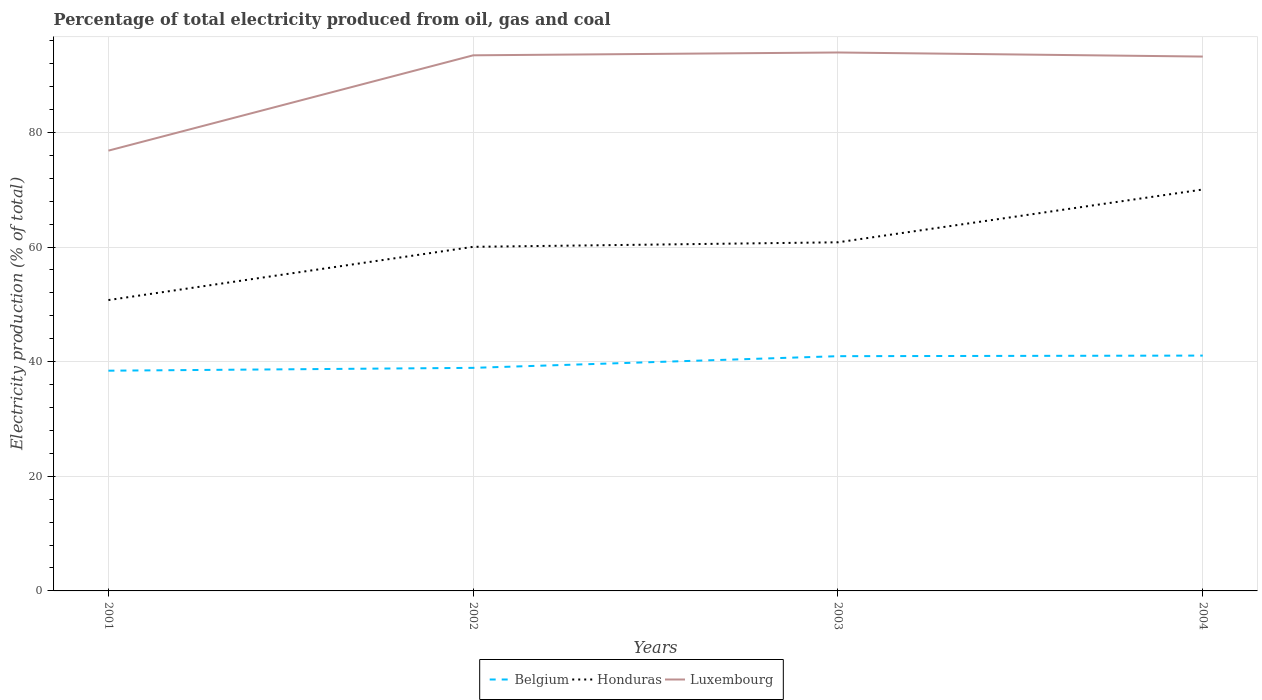How many different coloured lines are there?
Offer a very short reply. 3. Does the line corresponding to Luxembourg intersect with the line corresponding to Honduras?
Make the answer very short. No. Across all years, what is the maximum electricity production in in Belgium?
Offer a very short reply. 38.42. In which year was the electricity production in in Luxembourg maximum?
Provide a succinct answer. 2001. What is the total electricity production in in Belgium in the graph?
Your answer should be very brief. -0.1. What is the difference between the highest and the second highest electricity production in in Honduras?
Keep it short and to the point. 19.29. What is the difference between the highest and the lowest electricity production in in Honduras?
Provide a succinct answer. 2. How many lines are there?
Make the answer very short. 3. Are the values on the major ticks of Y-axis written in scientific E-notation?
Give a very brief answer. No. Does the graph contain any zero values?
Give a very brief answer. No. How many legend labels are there?
Ensure brevity in your answer.  3. How are the legend labels stacked?
Make the answer very short. Horizontal. What is the title of the graph?
Ensure brevity in your answer.  Percentage of total electricity produced from oil, gas and coal. What is the label or title of the Y-axis?
Make the answer very short. Electricity production (% of total). What is the Electricity production (% of total) in Belgium in 2001?
Provide a short and direct response. 38.42. What is the Electricity production (% of total) of Honduras in 2001?
Offer a terse response. 50.75. What is the Electricity production (% of total) of Luxembourg in 2001?
Your response must be concise. 76.82. What is the Electricity production (% of total) of Belgium in 2002?
Your response must be concise. 38.92. What is the Electricity production (% of total) in Honduras in 2002?
Provide a succinct answer. 60.03. What is the Electricity production (% of total) of Luxembourg in 2002?
Give a very brief answer. 93.45. What is the Electricity production (% of total) of Belgium in 2003?
Provide a short and direct response. 40.96. What is the Electricity production (% of total) of Honduras in 2003?
Your answer should be very brief. 60.82. What is the Electricity production (% of total) of Luxembourg in 2003?
Your answer should be very brief. 93.94. What is the Electricity production (% of total) of Belgium in 2004?
Your answer should be compact. 41.06. What is the Electricity production (% of total) in Honduras in 2004?
Offer a very short reply. 70.03. What is the Electricity production (% of total) of Luxembourg in 2004?
Provide a succinct answer. 93.23. Across all years, what is the maximum Electricity production (% of total) of Belgium?
Provide a short and direct response. 41.06. Across all years, what is the maximum Electricity production (% of total) in Honduras?
Your answer should be compact. 70.03. Across all years, what is the maximum Electricity production (% of total) of Luxembourg?
Provide a short and direct response. 93.94. Across all years, what is the minimum Electricity production (% of total) of Belgium?
Give a very brief answer. 38.42. Across all years, what is the minimum Electricity production (% of total) in Honduras?
Provide a succinct answer. 50.75. Across all years, what is the minimum Electricity production (% of total) in Luxembourg?
Make the answer very short. 76.82. What is the total Electricity production (% of total) of Belgium in the graph?
Provide a short and direct response. 159.36. What is the total Electricity production (% of total) of Honduras in the graph?
Make the answer very short. 241.64. What is the total Electricity production (% of total) in Luxembourg in the graph?
Your response must be concise. 357.43. What is the difference between the Electricity production (% of total) in Belgium in 2001 and that in 2002?
Your answer should be very brief. -0.49. What is the difference between the Electricity production (% of total) in Honduras in 2001 and that in 2002?
Your answer should be very brief. -9.29. What is the difference between the Electricity production (% of total) in Luxembourg in 2001 and that in 2002?
Your response must be concise. -16.63. What is the difference between the Electricity production (% of total) of Belgium in 2001 and that in 2003?
Provide a short and direct response. -2.53. What is the difference between the Electricity production (% of total) in Honduras in 2001 and that in 2003?
Ensure brevity in your answer.  -10.08. What is the difference between the Electricity production (% of total) of Luxembourg in 2001 and that in 2003?
Your response must be concise. -17.12. What is the difference between the Electricity production (% of total) in Belgium in 2001 and that in 2004?
Give a very brief answer. -2.63. What is the difference between the Electricity production (% of total) in Honduras in 2001 and that in 2004?
Your answer should be compact. -19.29. What is the difference between the Electricity production (% of total) of Luxembourg in 2001 and that in 2004?
Your answer should be very brief. -16.41. What is the difference between the Electricity production (% of total) in Belgium in 2002 and that in 2003?
Make the answer very short. -2.04. What is the difference between the Electricity production (% of total) in Honduras in 2002 and that in 2003?
Give a very brief answer. -0.79. What is the difference between the Electricity production (% of total) of Luxembourg in 2002 and that in 2003?
Offer a very short reply. -0.49. What is the difference between the Electricity production (% of total) of Belgium in 2002 and that in 2004?
Your answer should be compact. -2.14. What is the difference between the Electricity production (% of total) of Honduras in 2002 and that in 2004?
Your answer should be very brief. -10. What is the difference between the Electricity production (% of total) in Luxembourg in 2002 and that in 2004?
Make the answer very short. 0.22. What is the difference between the Electricity production (% of total) of Belgium in 2003 and that in 2004?
Your response must be concise. -0.1. What is the difference between the Electricity production (% of total) of Honduras in 2003 and that in 2004?
Provide a short and direct response. -9.21. What is the difference between the Electricity production (% of total) of Luxembourg in 2003 and that in 2004?
Your response must be concise. 0.71. What is the difference between the Electricity production (% of total) of Belgium in 2001 and the Electricity production (% of total) of Honduras in 2002?
Your answer should be very brief. -21.61. What is the difference between the Electricity production (% of total) of Belgium in 2001 and the Electricity production (% of total) of Luxembourg in 2002?
Your response must be concise. -55.02. What is the difference between the Electricity production (% of total) in Honduras in 2001 and the Electricity production (% of total) in Luxembourg in 2002?
Offer a very short reply. -42.7. What is the difference between the Electricity production (% of total) of Belgium in 2001 and the Electricity production (% of total) of Honduras in 2003?
Your response must be concise. -22.4. What is the difference between the Electricity production (% of total) of Belgium in 2001 and the Electricity production (% of total) of Luxembourg in 2003?
Provide a succinct answer. -55.52. What is the difference between the Electricity production (% of total) of Honduras in 2001 and the Electricity production (% of total) of Luxembourg in 2003?
Provide a short and direct response. -43.19. What is the difference between the Electricity production (% of total) in Belgium in 2001 and the Electricity production (% of total) in Honduras in 2004?
Your answer should be compact. -31.61. What is the difference between the Electricity production (% of total) of Belgium in 2001 and the Electricity production (% of total) of Luxembourg in 2004?
Your answer should be very brief. -54.81. What is the difference between the Electricity production (% of total) of Honduras in 2001 and the Electricity production (% of total) of Luxembourg in 2004?
Keep it short and to the point. -42.48. What is the difference between the Electricity production (% of total) in Belgium in 2002 and the Electricity production (% of total) in Honduras in 2003?
Ensure brevity in your answer.  -21.91. What is the difference between the Electricity production (% of total) of Belgium in 2002 and the Electricity production (% of total) of Luxembourg in 2003?
Your answer should be very brief. -55.02. What is the difference between the Electricity production (% of total) in Honduras in 2002 and the Electricity production (% of total) in Luxembourg in 2003?
Keep it short and to the point. -33.91. What is the difference between the Electricity production (% of total) of Belgium in 2002 and the Electricity production (% of total) of Honduras in 2004?
Provide a succinct answer. -31.11. What is the difference between the Electricity production (% of total) in Belgium in 2002 and the Electricity production (% of total) in Luxembourg in 2004?
Your answer should be compact. -54.31. What is the difference between the Electricity production (% of total) of Honduras in 2002 and the Electricity production (% of total) of Luxembourg in 2004?
Provide a short and direct response. -33.19. What is the difference between the Electricity production (% of total) in Belgium in 2003 and the Electricity production (% of total) in Honduras in 2004?
Keep it short and to the point. -29.08. What is the difference between the Electricity production (% of total) in Belgium in 2003 and the Electricity production (% of total) in Luxembourg in 2004?
Offer a terse response. -52.27. What is the difference between the Electricity production (% of total) of Honduras in 2003 and the Electricity production (% of total) of Luxembourg in 2004?
Provide a succinct answer. -32.4. What is the average Electricity production (% of total) of Belgium per year?
Keep it short and to the point. 39.84. What is the average Electricity production (% of total) of Honduras per year?
Your response must be concise. 60.41. What is the average Electricity production (% of total) in Luxembourg per year?
Offer a terse response. 89.36. In the year 2001, what is the difference between the Electricity production (% of total) of Belgium and Electricity production (% of total) of Honduras?
Provide a short and direct response. -12.32. In the year 2001, what is the difference between the Electricity production (% of total) of Belgium and Electricity production (% of total) of Luxembourg?
Make the answer very short. -38.39. In the year 2001, what is the difference between the Electricity production (% of total) in Honduras and Electricity production (% of total) in Luxembourg?
Give a very brief answer. -26.07. In the year 2002, what is the difference between the Electricity production (% of total) of Belgium and Electricity production (% of total) of Honduras?
Your response must be concise. -21.12. In the year 2002, what is the difference between the Electricity production (% of total) of Belgium and Electricity production (% of total) of Luxembourg?
Your answer should be compact. -54.53. In the year 2002, what is the difference between the Electricity production (% of total) of Honduras and Electricity production (% of total) of Luxembourg?
Ensure brevity in your answer.  -33.41. In the year 2003, what is the difference between the Electricity production (% of total) of Belgium and Electricity production (% of total) of Honduras?
Offer a very short reply. -19.87. In the year 2003, what is the difference between the Electricity production (% of total) of Belgium and Electricity production (% of total) of Luxembourg?
Provide a succinct answer. -52.98. In the year 2003, what is the difference between the Electricity production (% of total) of Honduras and Electricity production (% of total) of Luxembourg?
Keep it short and to the point. -33.12. In the year 2004, what is the difference between the Electricity production (% of total) in Belgium and Electricity production (% of total) in Honduras?
Provide a succinct answer. -28.97. In the year 2004, what is the difference between the Electricity production (% of total) in Belgium and Electricity production (% of total) in Luxembourg?
Give a very brief answer. -52.17. In the year 2004, what is the difference between the Electricity production (% of total) in Honduras and Electricity production (% of total) in Luxembourg?
Provide a short and direct response. -23.2. What is the ratio of the Electricity production (% of total) of Belgium in 2001 to that in 2002?
Offer a terse response. 0.99. What is the ratio of the Electricity production (% of total) in Honduras in 2001 to that in 2002?
Your response must be concise. 0.85. What is the ratio of the Electricity production (% of total) in Luxembourg in 2001 to that in 2002?
Ensure brevity in your answer.  0.82. What is the ratio of the Electricity production (% of total) in Belgium in 2001 to that in 2003?
Your response must be concise. 0.94. What is the ratio of the Electricity production (% of total) of Honduras in 2001 to that in 2003?
Give a very brief answer. 0.83. What is the ratio of the Electricity production (% of total) of Luxembourg in 2001 to that in 2003?
Make the answer very short. 0.82. What is the ratio of the Electricity production (% of total) of Belgium in 2001 to that in 2004?
Keep it short and to the point. 0.94. What is the ratio of the Electricity production (% of total) in Honduras in 2001 to that in 2004?
Offer a terse response. 0.72. What is the ratio of the Electricity production (% of total) of Luxembourg in 2001 to that in 2004?
Ensure brevity in your answer.  0.82. What is the ratio of the Electricity production (% of total) in Belgium in 2002 to that in 2003?
Offer a terse response. 0.95. What is the ratio of the Electricity production (% of total) in Luxembourg in 2002 to that in 2003?
Offer a very short reply. 0.99. What is the ratio of the Electricity production (% of total) in Belgium in 2002 to that in 2004?
Your answer should be very brief. 0.95. What is the ratio of the Electricity production (% of total) of Honduras in 2002 to that in 2004?
Your answer should be very brief. 0.86. What is the ratio of the Electricity production (% of total) of Honduras in 2003 to that in 2004?
Your answer should be compact. 0.87. What is the ratio of the Electricity production (% of total) of Luxembourg in 2003 to that in 2004?
Offer a very short reply. 1.01. What is the difference between the highest and the second highest Electricity production (% of total) in Belgium?
Provide a succinct answer. 0.1. What is the difference between the highest and the second highest Electricity production (% of total) of Honduras?
Your answer should be compact. 9.21. What is the difference between the highest and the second highest Electricity production (% of total) of Luxembourg?
Keep it short and to the point. 0.49. What is the difference between the highest and the lowest Electricity production (% of total) in Belgium?
Give a very brief answer. 2.63. What is the difference between the highest and the lowest Electricity production (% of total) of Honduras?
Your answer should be compact. 19.29. What is the difference between the highest and the lowest Electricity production (% of total) of Luxembourg?
Give a very brief answer. 17.12. 